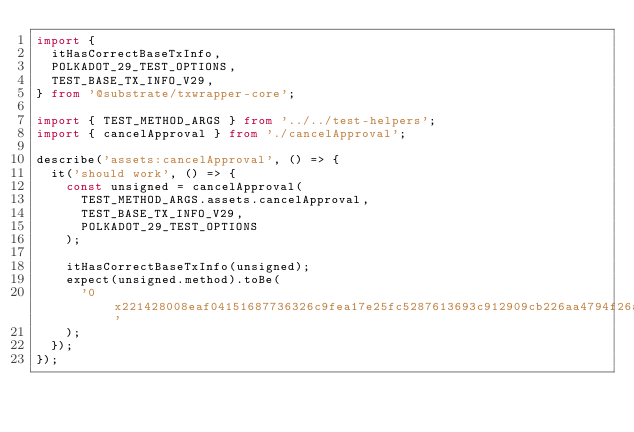Convert code to text. <code><loc_0><loc_0><loc_500><loc_500><_TypeScript_>import {
	itHasCorrectBaseTxInfo,
	POLKADOT_29_TEST_OPTIONS,
	TEST_BASE_TX_INFO_V29,
} from '@substrate/txwrapper-core';

import { TEST_METHOD_ARGS } from '../../test-helpers';
import { cancelApproval } from './cancelApproval';

describe('assets:cancelApproval', () => {
	it('should work', () => {
		const unsigned = cancelApproval(
			TEST_METHOD_ARGS.assets.cancelApproval,
			TEST_BASE_TX_INFO_V29,
			POLKADOT_29_TEST_OPTIONS
		);

		itHasCorrectBaseTxInfo(unsigned);
		expect(unsigned.method).toBe(
			'0x221428008eaf04151687736326c9fea17e25fc5287613693c912909cb226aa4794f26a48'
		);
	});
});
</code> 